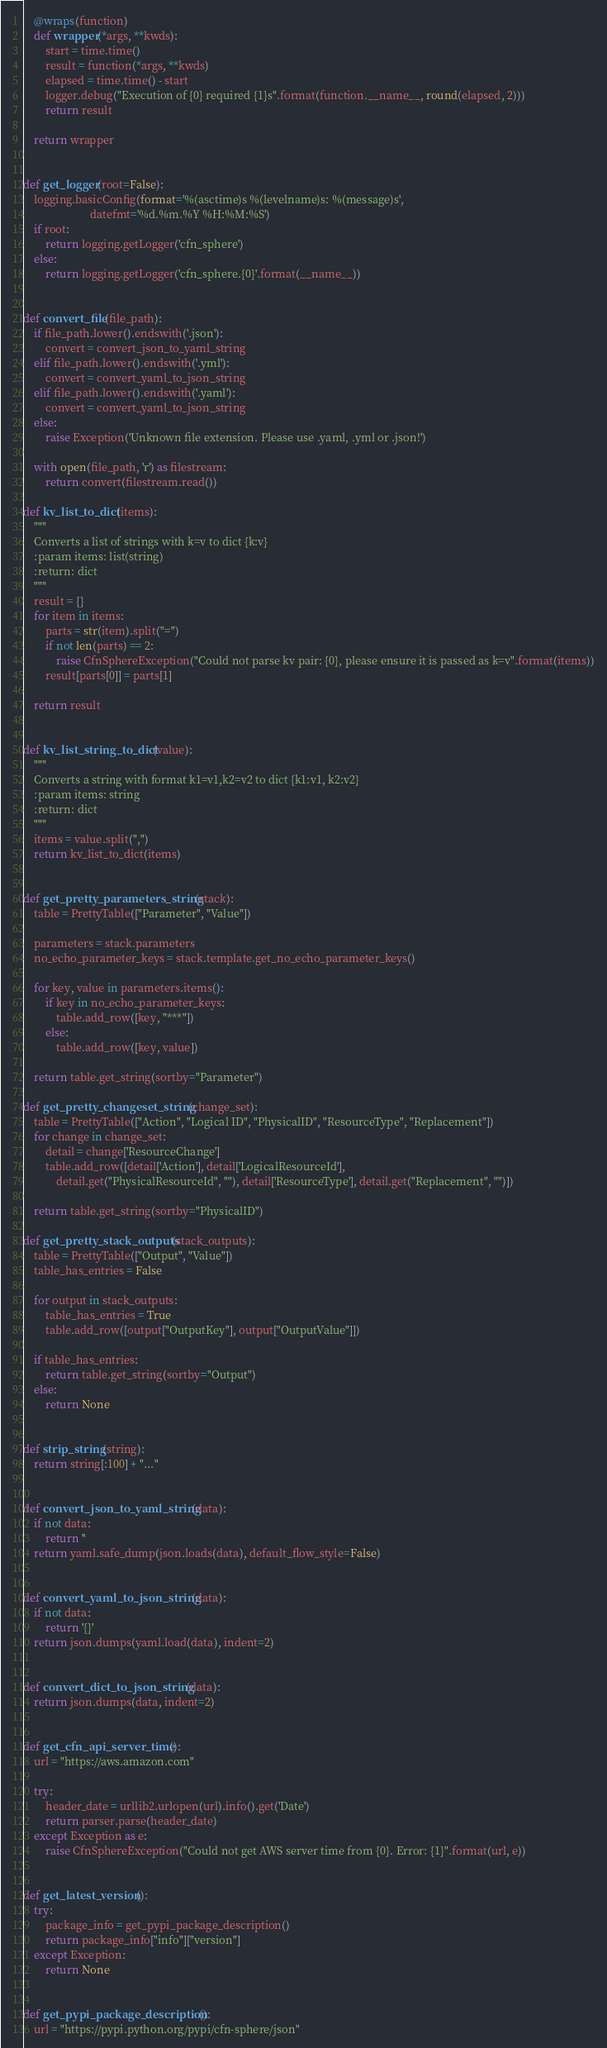<code> <loc_0><loc_0><loc_500><loc_500><_Python_>
    @wraps(function)
    def wrapper(*args, **kwds):
        start = time.time()
        result = function(*args, **kwds)
        elapsed = time.time() - start
        logger.debug("Execution of {0} required {1}s".format(function.__name__, round(elapsed, 2)))
        return result

    return wrapper


def get_logger(root=False):
    logging.basicConfig(format='%(asctime)s %(levelname)s: %(message)s',
                        datefmt='%d.%m.%Y %H:%M:%S')
    if root:
        return logging.getLogger('cfn_sphere')
    else:
        return logging.getLogger('cfn_sphere.{0}'.format(__name__))


def convert_file(file_path):
    if file_path.lower().endswith('.json'):
        convert = convert_json_to_yaml_string
    elif file_path.lower().endswith('.yml'):
        convert = convert_yaml_to_json_string
    elif file_path.lower().endswith('.yaml'):
        convert = convert_yaml_to_json_string
    else:
        raise Exception('Unknown file extension. Please use .yaml, .yml or .json!')

    with open(file_path, 'r') as filestream:
        return convert(filestream.read())

def kv_list_to_dict(items):
    """
    Converts a list of strings with k=v to dict {k:v}
    :param items: list(string)
    :return: dict
    """
    result = {}
    for item in items:
        parts = str(item).split("=")
        if not len(parts) == 2:
            raise CfnSphereException("Could not parse kv pair: {0}, please ensure it is passed as k=v".format(items))
        result[parts[0]] = parts[1]

    return result


def kv_list_string_to_dict(value):
    """
    Converts a string with format k1=v1,k2=v2 to dict {k1:v1, k2:v2}
    :param items: string
    :return: dict
    """
    items = value.split(",")
    return kv_list_to_dict(items)


def get_pretty_parameters_string(stack):
    table = PrettyTable(["Parameter", "Value"])

    parameters = stack.parameters
    no_echo_parameter_keys = stack.template.get_no_echo_parameter_keys()

    for key, value in parameters.items():
        if key in no_echo_parameter_keys:
            table.add_row([key, "***"])
        else:
            table.add_row([key, value])

    return table.get_string(sortby="Parameter")

def get_pretty_changeset_string(change_set):
    table = PrettyTable(["Action", "Logical ID", "PhysicalID", "ResourceType", "Replacement"])
    for change in change_set:
        detail = change['ResourceChange']
        table.add_row([detail['Action'], detail['LogicalResourceId'], 
            detail.get("PhysicalResourceId", ""), detail['ResourceType'], detail.get("Replacement", "")])

    return table.get_string(sortby="PhysicalID")

def get_pretty_stack_outputs(stack_outputs):
    table = PrettyTable(["Output", "Value"])
    table_has_entries = False

    for output in stack_outputs:
        table_has_entries = True
        table.add_row([output["OutputKey"], output["OutputValue"]])

    if table_has_entries:
        return table.get_string(sortby="Output")
    else:
        return None


def strip_string(string):
    return string[:100] + "..."


def convert_json_to_yaml_string(data):
    if not data:
        return ''
    return yaml.safe_dump(json.loads(data), default_flow_style=False)


def convert_yaml_to_json_string(data):
    if not data:
        return '{}'
    return json.dumps(yaml.load(data), indent=2)


def convert_dict_to_json_string(data):
    return json.dumps(data, indent=2)


def get_cfn_api_server_time():
    url = "https://aws.amazon.com"

    try:
        header_date = urllib2.urlopen(url).info().get('Date')
        return parser.parse(header_date)
    except Exception as e:
        raise CfnSphereException("Could not get AWS server time from {0}. Error: {1}".format(url, e))


def get_latest_version():
    try:
        package_info = get_pypi_package_description()
        return package_info["info"]["version"]
    except Exception:
        return None


def get_pypi_package_description():
    url = "https://pypi.python.org/pypi/cfn-sphere/json"
</code> 